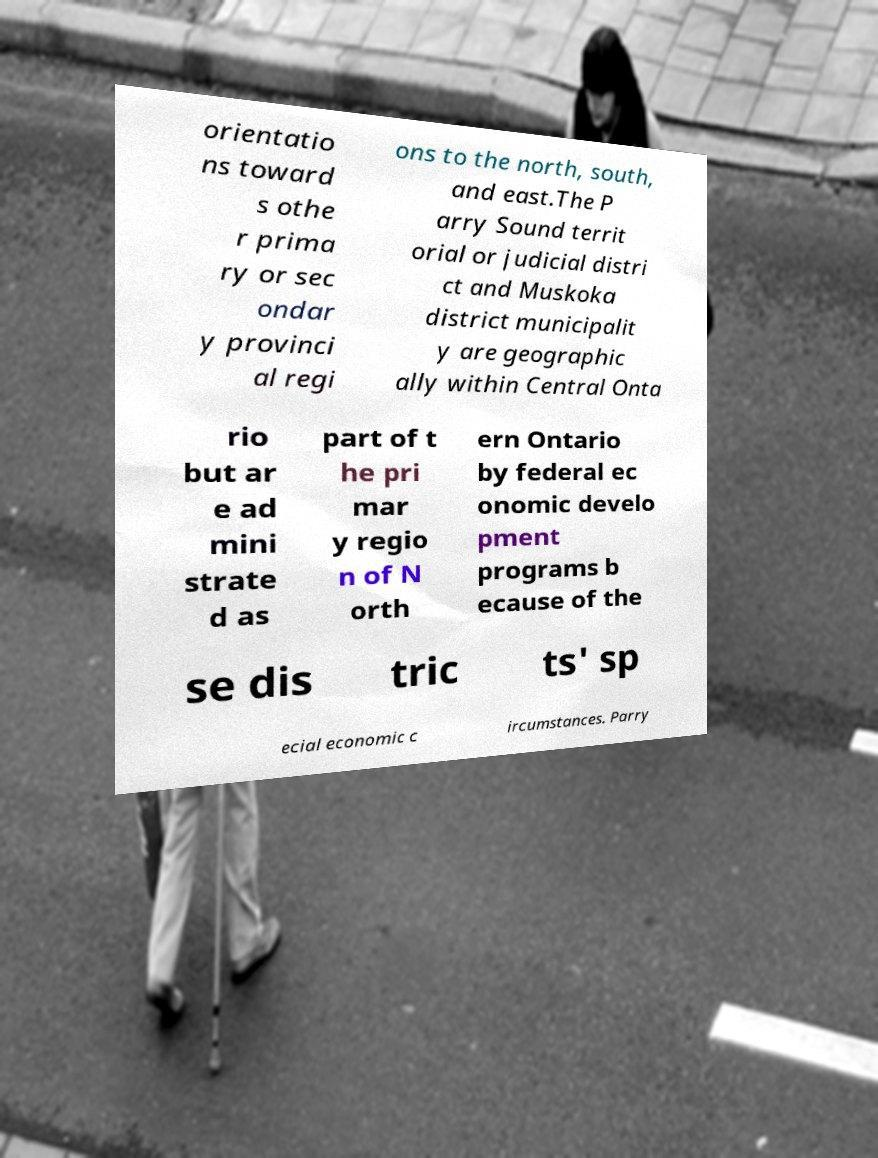Please read and relay the text visible in this image. What does it say? orientatio ns toward s othe r prima ry or sec ondar y provinci al regi ons to the north, south, and east.The P arry Sound territ orial or judicial distri ct and Muskoka district municipalit y are geographic ally within Central Onta rio but ar e ad mini strate d as part of t he pri mar y regio n of N orth ern Ontario by federal ec onomic develo pment programs b ecause of the se dis tric ts' sp ecial economic c ircumstances. Parry 